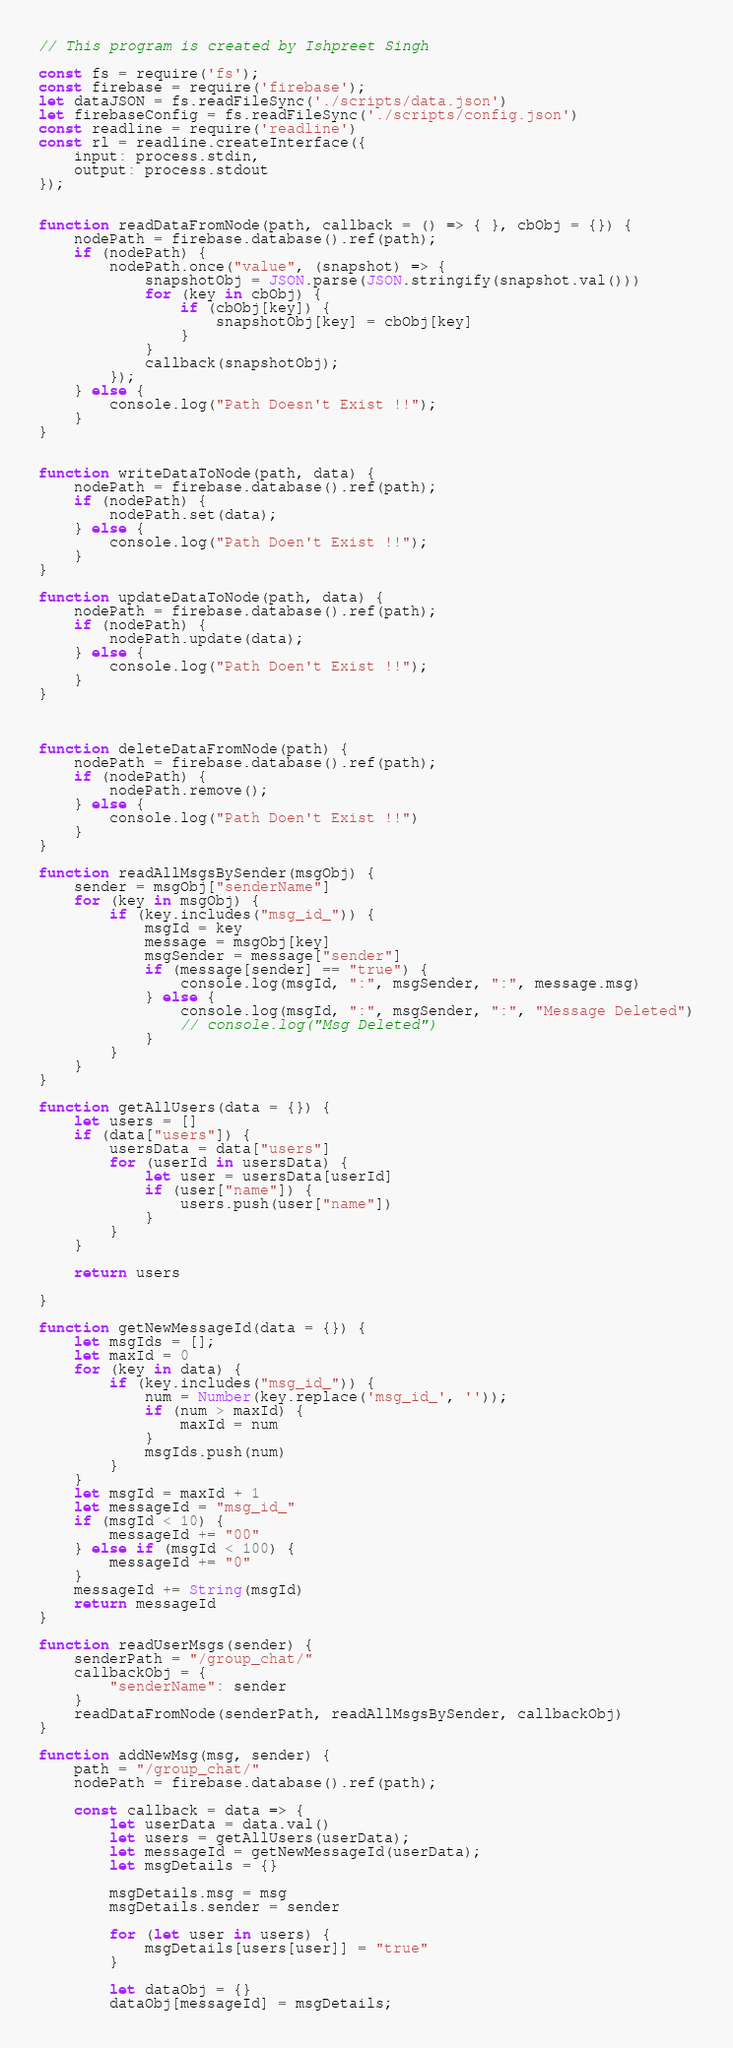Convert code to text. <code><loc_0><loc_0><loc_500><loc_500><_JavaScript_>// This program is created by Ishpreet Singh

const fs = require('fs');
const firebase = require('firebase');
let dataJSON = fs.readFileSync('./scripts/data.json')
let firebaseConfig = fs.readFileSync('./scripts/config.json')
const readline = require('readline')
const rl = readline.createInterface({
    input: process.stdin,
    output: process.stdout
});


function readDataFromNode(path, callback = () => { }, cbObj = {}) {
    nodePath = firebase.database().ref(path);
    if (nodePath) {
        nodePath.once("value", (snapshot) => {
            snapshotObj = JSON.parse(JSON.stringify(snapshot.val()))
            for (key in cbObj) {
                if (cbObj[key]) {
                    snapshotObj[key] = cbObj[key]
                }
            }
            callback(snapshotObj);
        });
    } else {
        console.log("Path Doesn't Exist !!");
    }
}


function writeDataToNode(path, data) {
    nodePath = firebase.database().ref(path);
    if (nodePath) {
        nodePath.set(data);
    } else {
        console.log("Path Doen't Exist !!");
    }
}

function updateDataToNode(path, data) {
    nodePath = firebase.database().ref(path);
    if (nodePath) {
        nodePath.update(data);
    } else {
        console.log("Path Doen't Exist !!");
    }
}



function deleteDataFromNode(path) {
    nodePath = firebase.database().ref(path);
    if (nodePath) {
        nodePath.remove();
    } else {
        console.log("Path Doen't Exist !!")
    }
}

function readAllMsgsBySender(msgObj) {
    sender = msgObj["senderName"]
    for (key in msgObj) {
        if (key.includes("msg_id_")) {
            msgId = key
            message = msgObj[key]
            msgSender = message["sender"]
            if (message[sender] == "true") {
                console.log(msgId, ":", msgSender, ":", message.msg)
            } else {
                console.log(msgId, ":", msgSender, ":", "Message Deleted")
                // console.log("Msg Deleted")
            }
        }
    }
}

function getAllUsers(data = {}) {
    let users = []
    if (data["users"]) {
        usersData = data["users"]
        for (userId in usersData) {
            let user = usersData[userId]
            if (user["name"]) {
                users.push(user["name"])
            }
        }
    }

    return users

}

function getNewMessageId(data = {}) {
    let msgIds = [];
    let maxId = 0
    for (key in data) {
        if (key.includes("msg_id_")) {
            num = Number(key.replace('msg_id_', ''));
            if (num > maxId) {
                maxId = num
            }
            msgIds.push(num)
        }
    }
    let msgId = maxId + 1
    let messageId = "msg_id_"
    if (msgId < 10) {
        messageId += "00"
    } else if (msgId < 100) {
        messageId += "0"
    }
    messageId += String(msgId)
    return messageId
}

function readUserMsgs(sender) {
    senderPath = "/group_chat/"
    callbackObj = {
        "senderName": sender
    }
    readDataFromNode(senderPath, readAllMsgsBySender, callbackObj)
}

function addNewMsg(msg, sender) {
    path = "/group_chat/"
    nodePath = firebase.database().ref(path);

    const callback = data => {
        let userData = data.val()
        let users = getAllUsers(userData);
        let messageId = getNewMessageId(userData);
        let msgDetails = {}

        msgDetails.msg = msg
        msgDetails.sender = sender

        for (let user in users) {
            msgDetails[users[user]] = "true"
        }

        let dataObj = {}
        dataObj[messageId] = msgDetails;
</code> 